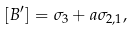<formula> <loc_0><loc_0><loc_500><loc_500>[ B ^ { \prime } ] = \sigma _ { 3 } + a \sigma _ { 2 , 1 } ,</formula> 